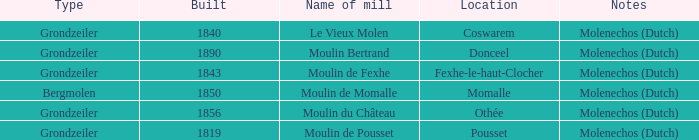What is the Name of the Grondzeiler Mill? Le Vieux Molen, Moulin Bertrand, Moulin de Fexhe, Moulin du Château, Moulin de Pousset. 